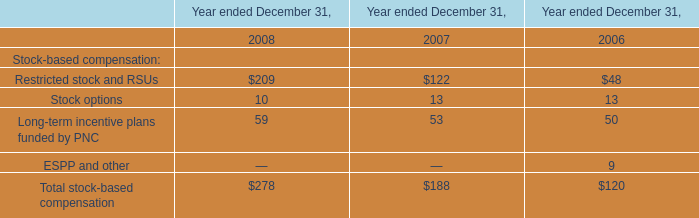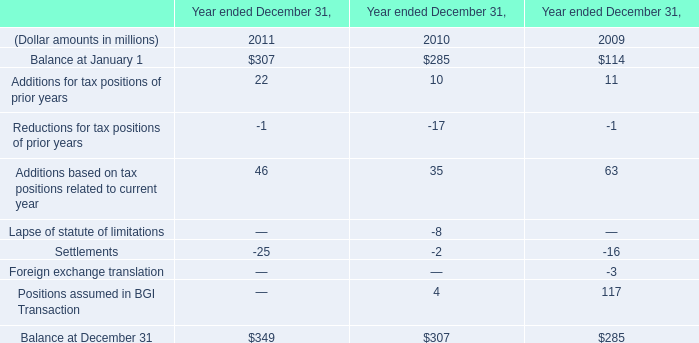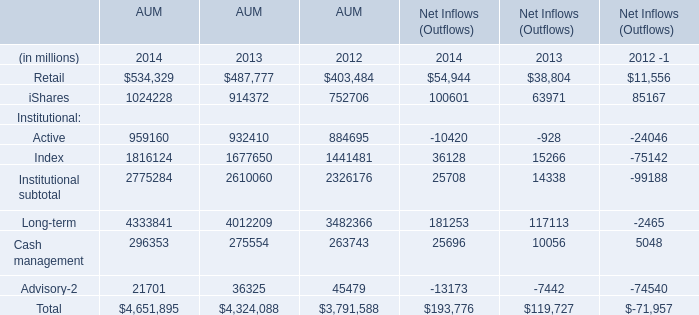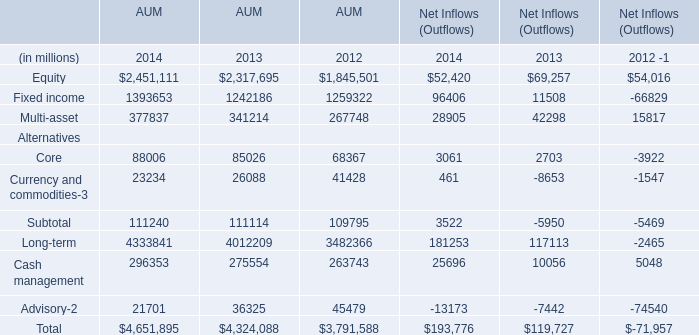Which year is AUM Active the most? (in year) 
Answer: 2014. 